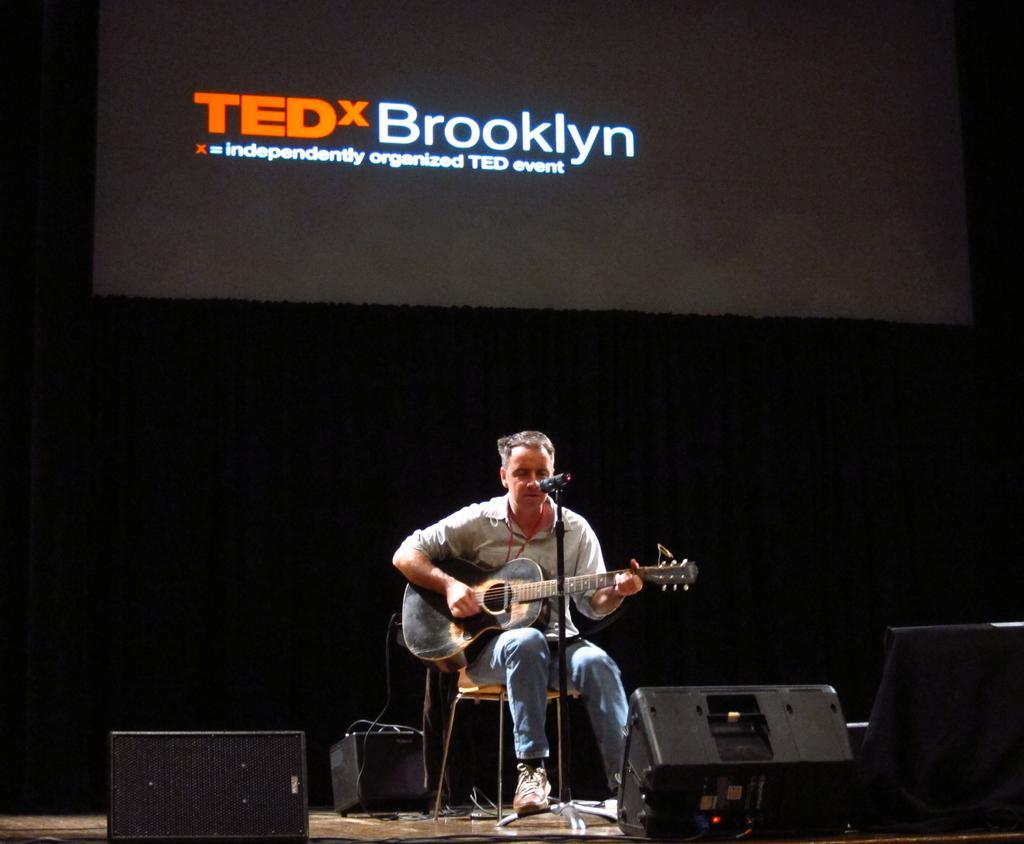Please provide a concise description of this image. A screen is on curtain. This man is sitting on chair and playing guitar in-front of mic. On floor there are speakers. 